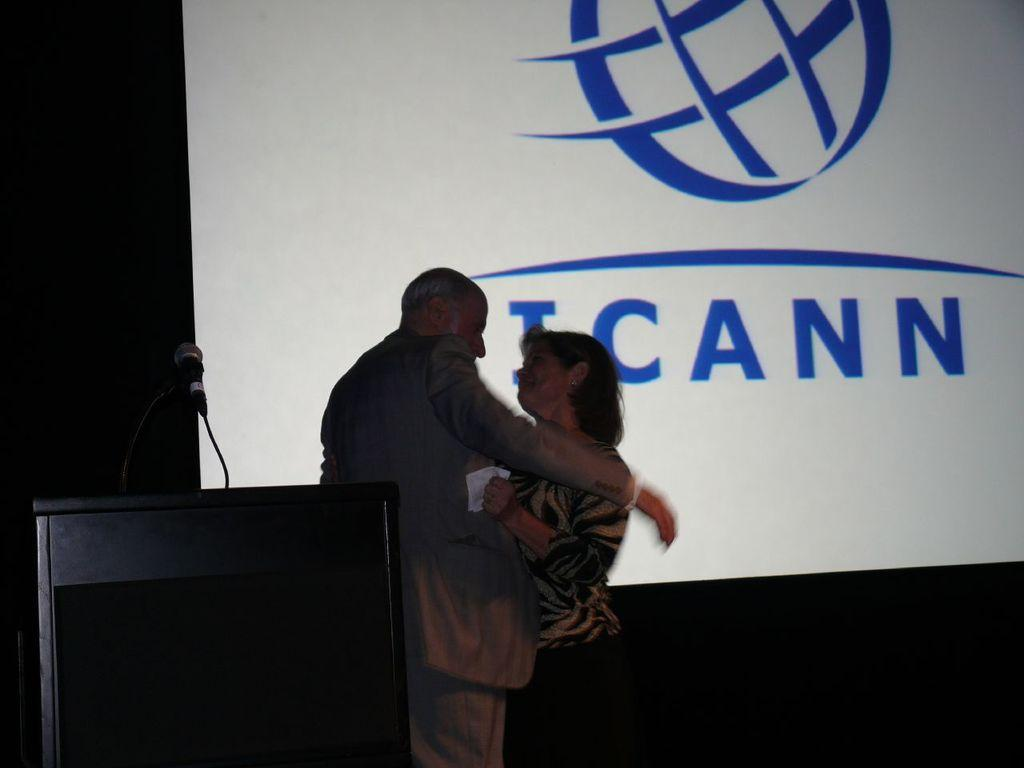Who are the people in the image? There is a man and a lady in the image. What is the man and lady standing near? They are standing near a podium. What is on the podium? There is a microphone on the podium. What can be seen in the background of the image? There is a screen in the background of the image. What type of paper is the man holding in the image? There is no paper visible in the image; the man and lady are standing near a podium with a microphone. 